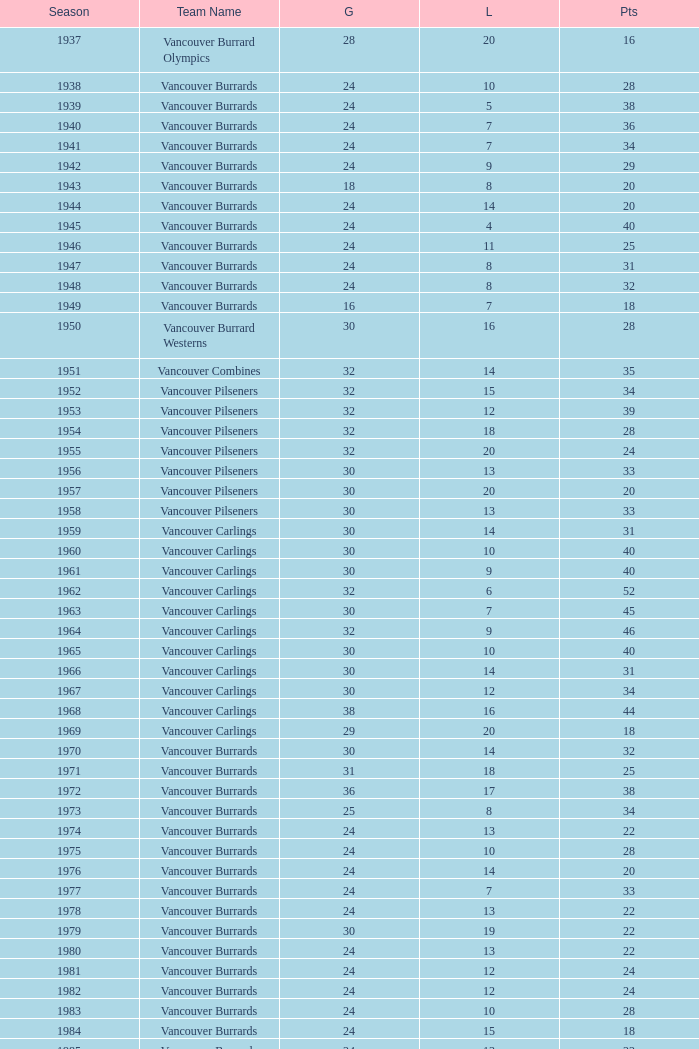What's the total number of games with more than 20 points for the 1976 season? 0.0. 